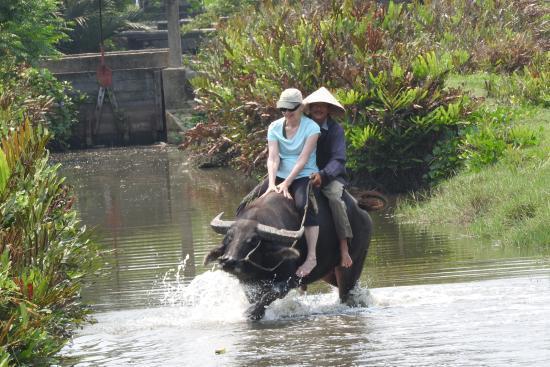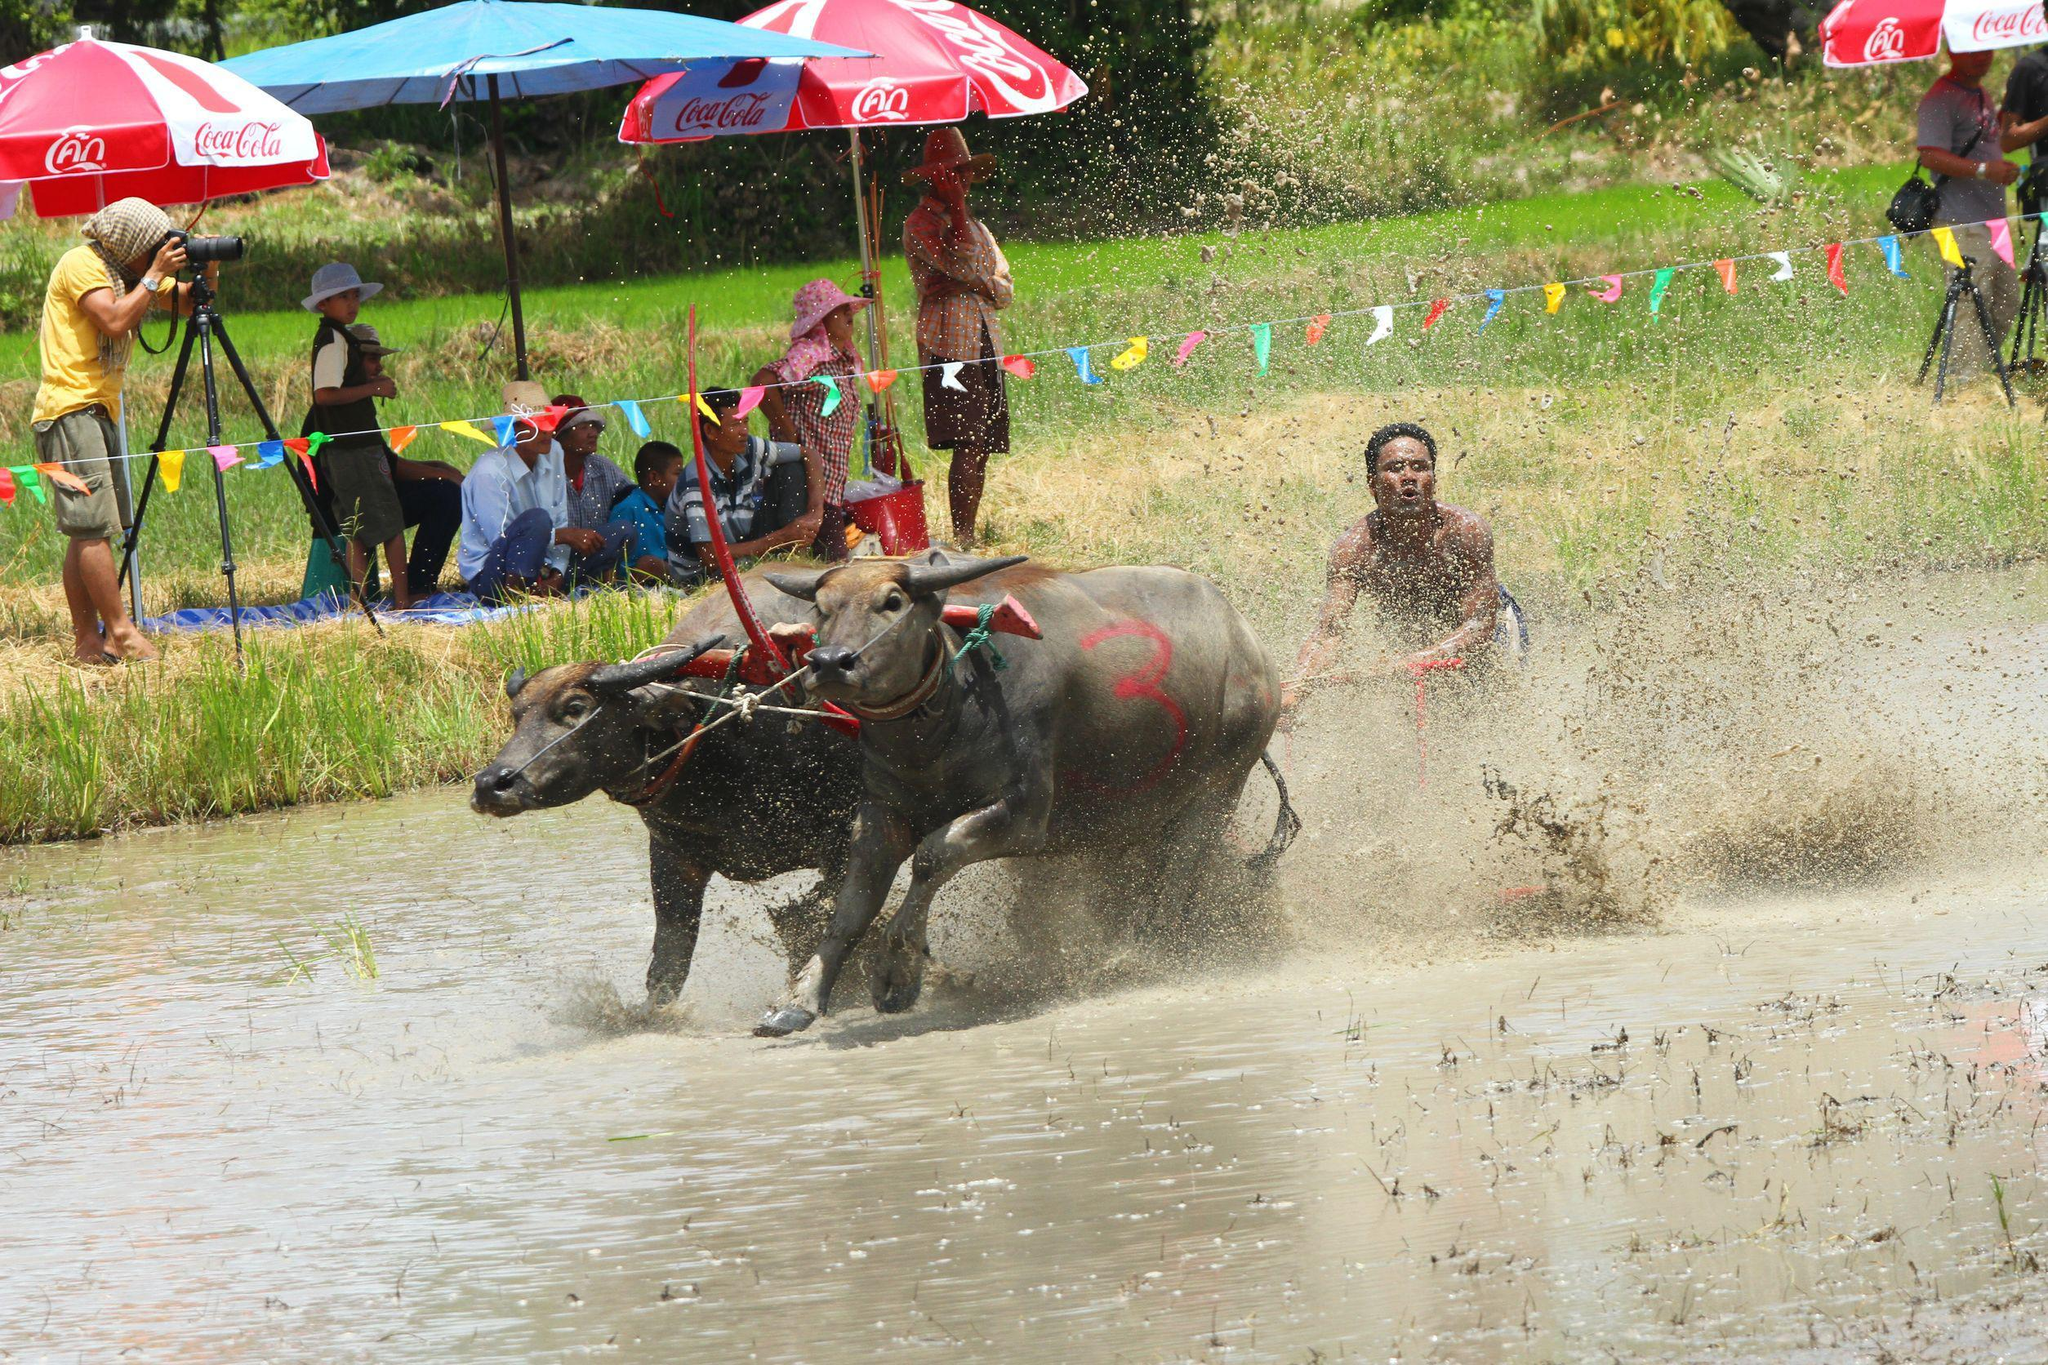The first image is the image on the left, the second image is the image on the right. Evaluate the accuracy of this statement regarding the images: "At least one person is behind a hitched team of two water buffalo in one image.". Is it true? Answer yes or no. Yes. The first image is the image on the left, the second image is the image on the right. For the images shown, is this caption "A water buffalo is being used to pull a person." true? Answer yes or no. Yes. 